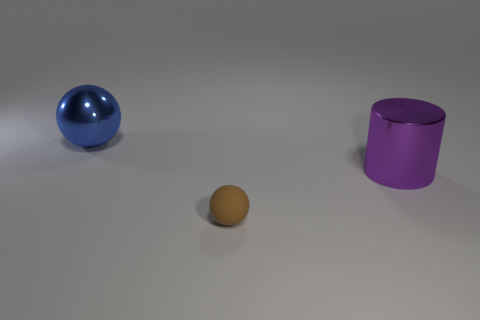Add 3 small matte spheres. How many objects exist? 6 Subtract all balls. How many objects are left? 1 Subtract all large gray blocks. Subtract all blue things. How many objects are left? 2 Add 3 large blue balls. How many large blue balls are left? 4 Add 1 big cyan rubber balls. How many big cyan rubber balls exist? 1 Subtract 0 purple blocks. How many objects are left? 3 Subtract all green cylinders. Subtract all gray cubes. How many cylinders are left? 1 